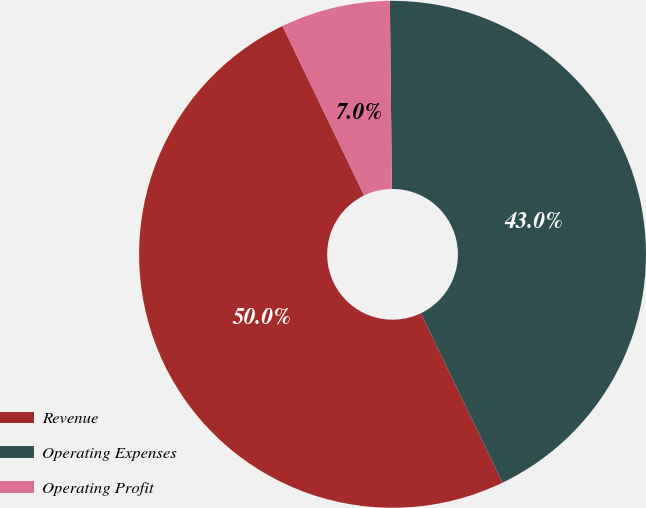Convert chart to OTSL. <chart><loc_0><loc_0><loc_500><loc_500><pie_chart><fcel>Revenue<fcel>Operating Expenses<fcel>Operating Profit<nl><fcel>50.0%<fcel>43.02%<fcel>6.98%<nl></chart> 